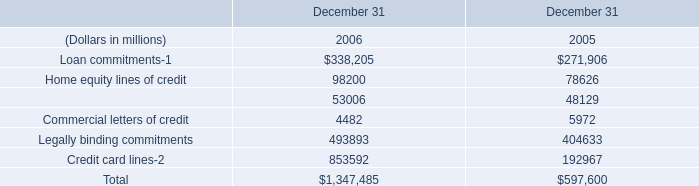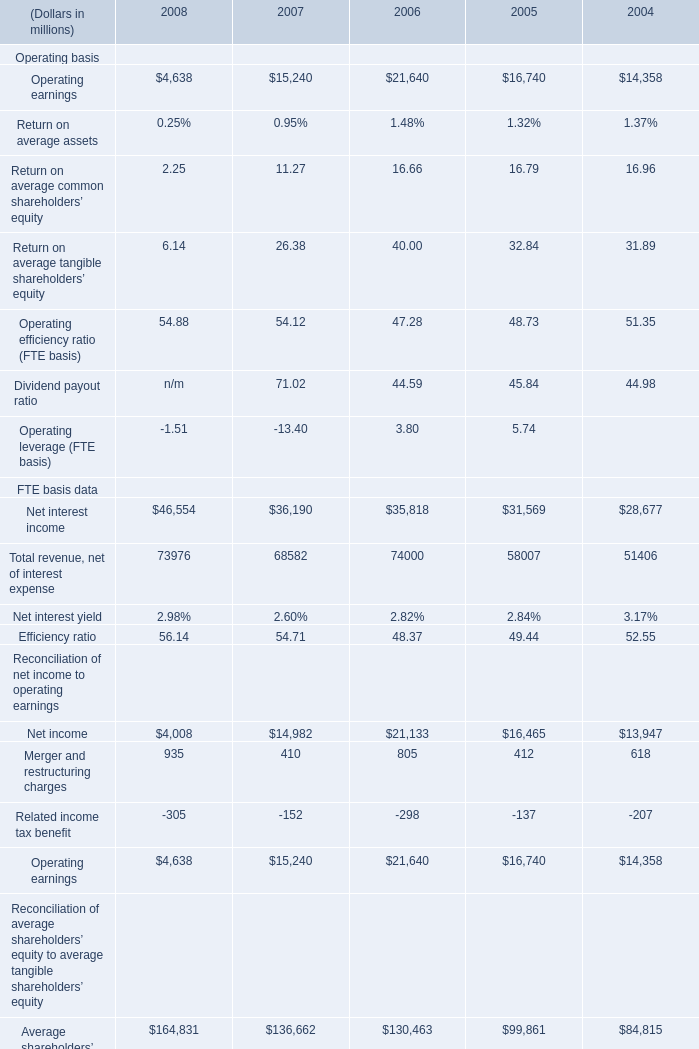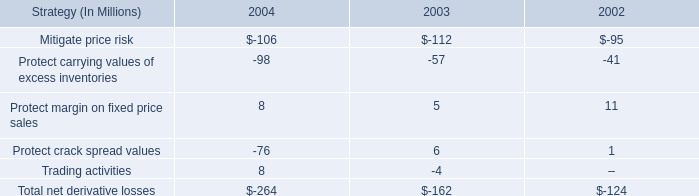what's the total amount of Net interest income FTE basis data of 2006, Loan commitments of December 31 2006, and Average tangible shareholders’ equity Reconciliation of average shareholders’ equity to average tangible shareholders’ equity of 2006 ? 
Computations: ((35818.0 + 338205.0) + 54099.0)
Answer: 428122.0. 